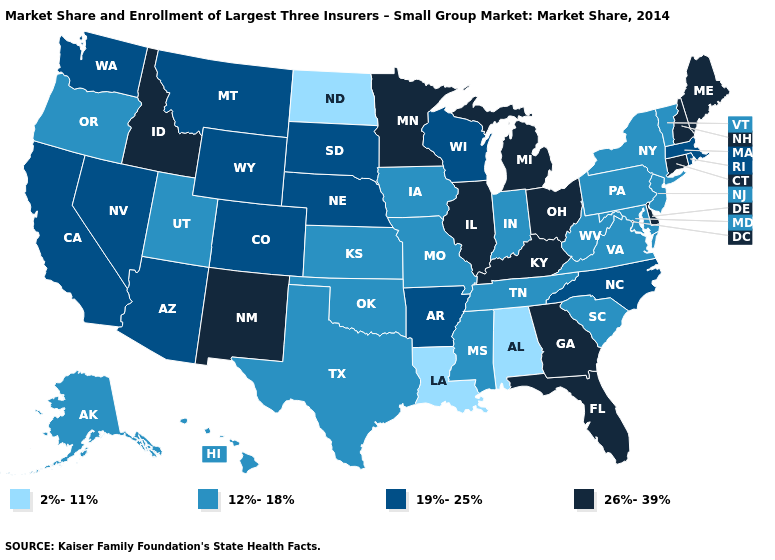What is the value of Utah?
Quick response, please. 12%-18%. Which states have the highest value in the USA?
Write a very short answer. Connecticut, Delaware, Florida, Georgia, Idaho, Illinois, Kentucky, Maine, Michigan, Minnesota, New Hampshire, New Mexico, Ohio. What is the value of Mississippi?
Answer briefly. 12%-18%. What is the value of Delaware?
Write a very short answer. 26%-39%. Name the states that have a value in the range 2%-11%?
Give a very brief answer. Alabama, Louisiana, North Dakota. Name the states that have a value in the range 12%-18%?
Quick response, please. Alaska, Hawaii, Indiana, Iowa, Kansas, Maryland, Mississippi, Missouri, New Jersey, New York, Oklahoma, Oregon, Pennsylvania, South Carolina, Tennessee, Texas, Utah, Vermont, Virginia, West Virginia. Among the states that border New Jersey , does Delaware have the lowest value?
Write a very short answer. No. Which states have the highest value in the USA?
Answer briefly. Connecticut, Delaware, Florida, Georgia, Idaho, Illinois, Kentucky, Maine, Michigan, Minnesota, New Hampshire, New Mexico, Ohio. What is the value of West Virginia?
Quick response, please. 12%-18%. Which states have the lowest value in the South?
Keep it brief. Alabama, Louisiana. What is the value of Idaho?
Quick response, please. 26%-39%. Does South Dakota have the highest value in the MidWest?
Write a very short answer. No. Name the states that have a value in the range 26%-39%?
Give a very brief answer. Connecticut, Delaware, Florida, Georgia, Idaho, Illinois, Kentucky, Maine, Michigan, Minnesota, New Hampshire, New Mexico, Ohio. Is the legend a continuous bar?
Answer briefly. No. What is the value of Arizona?
Concise answer only. 19%-25%. 